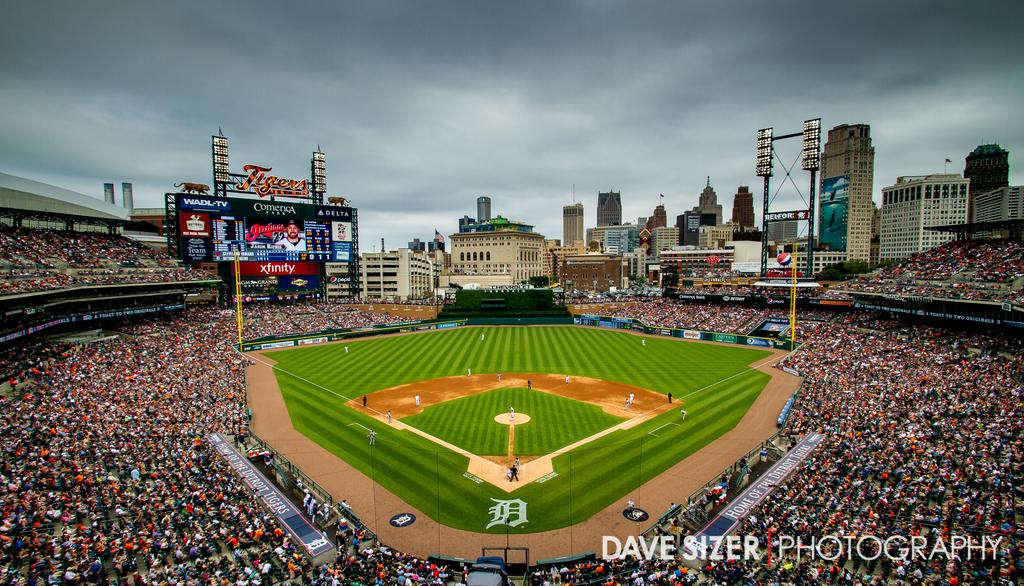<image>
Offer a succinct explanation of the picture presented. a field that has the name of Dave Sizer on it 